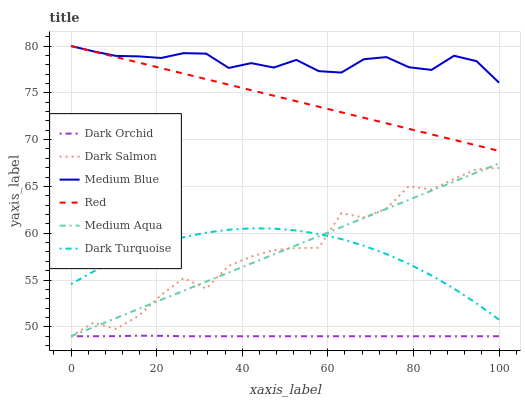Does Dark Orchid have the minimum area under the curve?
Answer yes or no. Yes. Does Medium Blue have the maximum area under the curve?
Answer yes or no. Yes. Does Dark Salmon have the minimum area under the curve?
Answer yes or no. No. Does Dark Salmon have the maximum area under the curve?
Answer yes or no. No. Is Medium Aqua the smoothest?
Answer yes or no. Yes. Is Dark Salmon the roughest?
Answer yes or no. Yes. Is Medium Blue the smoothest?
Answer yes or no. No. Is Medium Blue the roughest?
Answer yes or no. No. Does Dark Salmon have the lowest value?
Answer yes or no. Yes. Does Medium Blue have the lowest value?
Answer yes or no. No. Does Red have the highest value?
Answer yes or no. Yes. Does Dark Salmon have the highest value?
Answer yes or no. No. Is Dark Salmon less than Red?
Answer yes or no. Yes. Is Medium Blue greater than Dark Salmon?
Answer yes or no. Yes. Does Medium Blue intersect Red?
Answer yes or no. Yes. Is Medium Blue less than Red?
Answer yes or no. No. Is Medium Blue greater than Red?
Answer yes or no. No. Does Dark Salmon intersect Red?
Answer yes or no. No. 